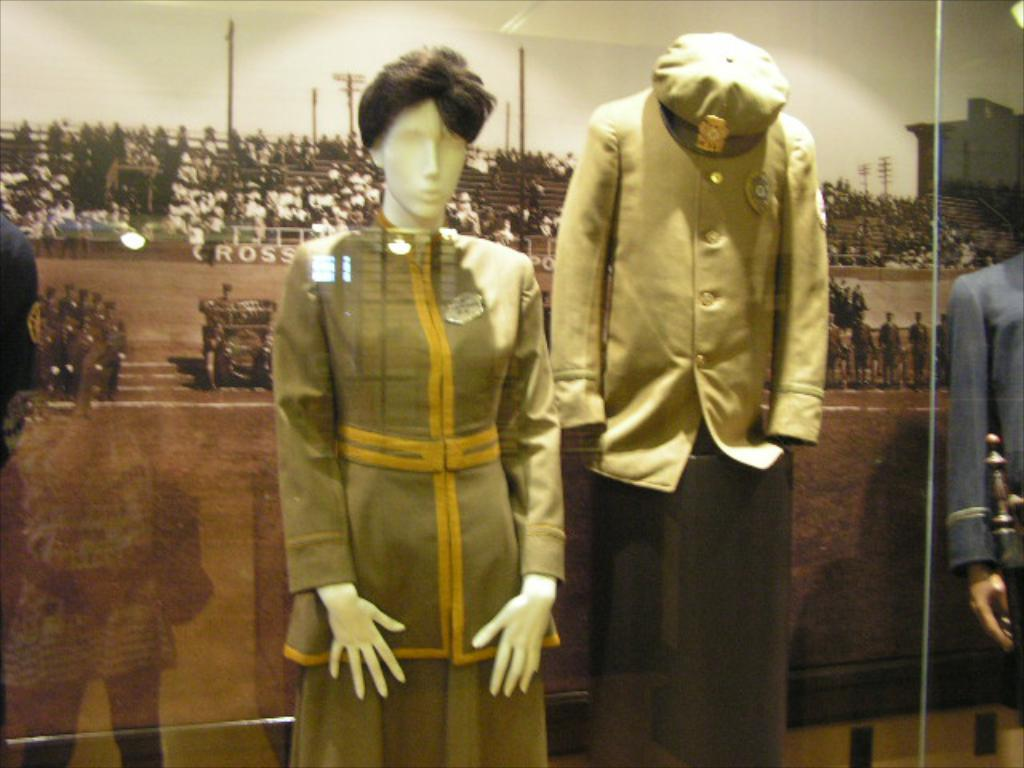What type of objects are dressed in the image? There are mannequins with dresses in the image. What can be seen in the background of the image? There is a poster in the background of the image. What is depicted on the poster? The poster features people and poles. Can you see the mannequins smiling in the image? There is no indication of the mannequins' facial expressions in the image, so it cannot be determined if they are smiling. 